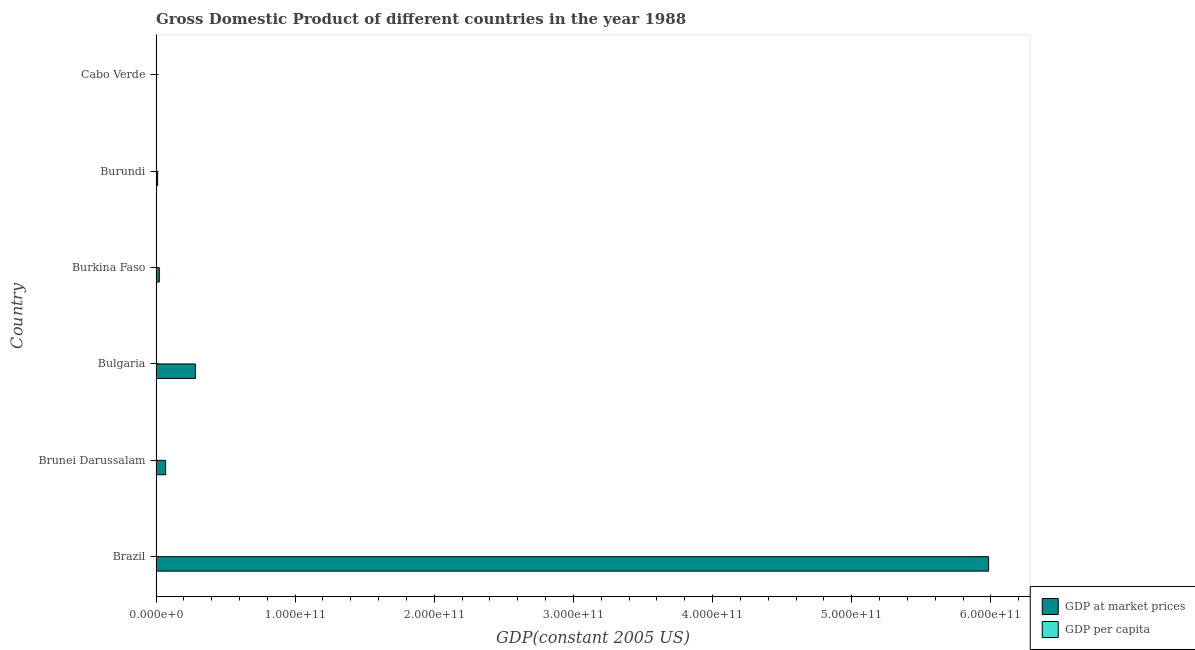How many different coloured bars are there?
Your answer should be very brief. 2. How many groups of bars are there?
Your answer should be very brief. 6. How many bars are there on the 3rd tick from the top?
Make the answer very short. 2. What is the label of the 4th group of bars from the top?
Give a very brief answer. Bulgaria. What is the gdp per capita in Burkina Faso?
Provide a short and direct response. 281.81. Across all countries, what is the maximum gdp at market prices?
Give a very brief answer. 5.98e+11. Across all countries, what is the minimum gdp at market prices?
Make the answer very short. 2.35e+08. In which country was the gdp at market prices maximum?
Keep it short and to the point. Brazil. In which country was the gdp at market prices minimum?
Provide a succinct answer. Cabo Verde. What is the total gdp per capita in the graph?
Your response must be concise. 3.69e+04. What is the difference between the gdp per capita in Burkina Faso and that in Cabo Verde?
Ensure brevity in your answer.  -432.06. What is the difference between the gdp per capita in Bulgaria and the gdp at market prices in Brazil?
Give a very brief answer. -5.98e+11. What is the average gdp per capita per country?
Give a very brief answer. 6148.14. What is the difference between the gdp per capita and gdp at market prices in Brunei Darussalam?
Your answer should be very brief. -6.89e+09. In how many countries, is the gdp per capita greater than 460000000000 US$?
Make the answer very short. 0. What is the ratio of the gdp per capita in Brazil to that in Brunei Darussalam?
Your answer should be very brief. 0.14. Is the gdp at market prices in Brunei Darussalam less than that in Bulgaria?
Make the answer very short. Yes. What is the difference between the highest and the second highest gdp at market prices?
Keep it short and to the point. 5.70e+11. What is the difference between the highest and the lowest gdp per capita?
Make the answer very short. 2.82e+04. Is the sum of the gdp per capita in Brazil and Burkina Faso greater than the maximum gdp at market prices across all countries?
Keep it short and to the point. No. What does the 1st bar from the top in Bulgaria represents?
Keep it short and to the point. GDP per capita. What does the 2nd bar from the bottom in Burundi represents?
Your answer should be compact. GDP per capita. How many bars are there?
Offer a terse response. 12. Are all the bars in the graph horizontal?
Your answer should be very brief. Yes. How many countries are there in the graph?
Your response must be concise. 6. What is the difference between two consecutive major ticks on the X-axis?
Offer a very short reply. 1.00e+11. Are the values on the major ticks of X-axis written in scientific E-notation?
Keep it short and to the point. Yes. How are the legend labels stacked?
Make the answer very short. Vertical. What is the title of the graph?
Give a very brief answer. Gross Domestic Product of different countries in the year 1988. Does "Diesel" appear as one of the legend labels in the graph?
Keep it short and to the point. No. What is the label or title of the X-axis?
Give a very brief answer. GDP(constant 2005 US). What is the label or title of the Y-axis?
Your answer should be compact. Country. What is the GDP(constant 2005 US) in GDP at market prices in Brazil?
Provide a short and direct response. 5.98e+11. What is the GDP(constant 2005 US) of GDP per capita in Brazil?
Your answer should be compact. 4122.42. What is the GDP(constant 2005 US) of GDP at market prices in Brunei Darussalam?
Keep it short and to the point. 6.89e+09. What is the GDP(constant 2005 US) in GDP per capita in Brunei Darussalam?
Give a very brief answer. 2.84e+04. What is the GDP(constant 2005 US) of GDP at market prices in Bulgaria?
Ensure brevity in your answer.  2.83e+1. What is the GDP(constant 2005 US) of GDP per capita in Bulgaria?
Your answer should be very brief. 3152.69. What is the GDP(constant 2005 US) in GDP at market prices in Burkina Faso?
Provide a short and direct response. 2.35e+09. What is the GDP(constant 2005 US) of GDP per capita in Burkina Faso?
Your answer should be very brief. 281.81. What is the GDP(constant 2005 US) in GDP at market prices in Burundi?
Offer a terse response. 1.17e+09. What is the GDP(constant 2005 US) of GDP per capita in Burundi?
Make the answer very short. 220.82. What is the GDP(constant 2005 US) of GDP at market prices in Cabo Verde?
Ensure brevity in your answer.  2.35e+08. What is the GDP(constant 2005 US) in GDP per capita in Cabo Verde?
Provide a short and direct response. 713.87. Across all countries, what is the maximum GDP(constant 2005 US) of GDP at market prices?
Your response must be concise. 5.98e+11. Across all countries, what is the maximum GDP(constant 2005 US) in GDP per capita?
Offer a very short reply. 2.84e+04. Across all countries, what is the minimum GDP(constant 2005 US) in GDP at market prices?
Make the answer very short. 2.35e+08. Across all countries, what is the minimum GDP(constant 2005 US) in GDP per capita?
Give a very brief answer. 220.82. What is the total GDP(constant 2005 US) of GDP at market prices in the graph?
Offer a terse response. 6.37e+11. What is the total GDP(constant 2005 US) of GDP per capita in the graph?
Your answer should be very brief. 3.69e+04. What is the difference between the GDP(constant 2005 US) in GDP at market prices in Brazil and that in Brunei Darussalam?
Give a very brief answer. 5.91e+11. What is the difference between the GDP(constant 2005 US) of GDP per capita in Brazil and that in Brunei Darussalam?
Give a very brief answer. -2.43e+04. What is the difference between the GDP(constant 2005 US) of GDP at market prices in Brazil and that in Bulgaria?
Make the answer very short. 5.70e+11. What is the difference between the GDP(constant 2005 US) of GDP per capita in Brazil and that in Bulgaria?
Provide a succinct answer. 969.72. What is the difference between the GDP(constant 2005 US) of GDP at market prices in Brazil and that in Burkina Faso?
Make the answer very short. 5.96e+11. What is the difference between the GDP(constant 2005 US) in GDP per capita in Brazil and that in Burkina Faso?
Your response must be concise. 3840.61. What is the difference between the GDP(constant 2005 US) of GDP at market prices in Brazil and that in Burundi?
Provide a short and direct response. 5.97e+11. What is the difference between the GDP(constant 2005 US) in GDP per capita in Brazil and that in Burundi?
Provide a succinct answer. 3901.59. What is the difference between the GDP(constant 2005 US) in GDP at market prices in Brazil and that in Cabo Verde?
Your answer should be very brief. 5.98e+11. What is the difference between the GDP(constant 2005 US) in GDP per capita in Brazil and that in Cabo Verde?
Make the answer very short. 3408.55. What is the difference between the GDP(constant 2005 US) in GDP at market prices in Brunei Darussalam and that in Bulgaria?
Provide a succinct answer. -2.14e+1. What is the difference between the GDP(constant 2005 US) of GDP per capita in Brunei Darussalam and that in Bulgaria?
Ensure brevity in your answer.  2.52e+04. What is the difference between the GDP(constant 2005 US) of GDP at market prices in Brunei Darussalam and that in Burkina Faso?
Provide a succinct answer. 4.54e+09. What is the difference between the GDP(constant 2005 US) of GDP per capita in Brunei Darussalam and that in Burkina Faso?
Offer a very short reply. 2.81e+04. What is the difference between the GDP(constant 2005 US) of GDP at market prices in Brunei Darussalam and that in Burundi?
Make the answer very short. 5.73e+09. What is the difference between the GDP(constant 2005 US) in GDP per capita in Brunei Darussalam and that in Burundi?
Your response must be concise. 2.82e+04. What is the difference between the GDP(constant 2005 US) in GDP at market prices in Brunei Darussalam and that in Cabo Verde?
Provide a succinct answer. 6.66e+09. What is the difference between the GDP(constant 2005 US) of GDP per capita in Brunei Darussalam and that in Cabo Verde?
Make the answer very short. 2.77e+04. What is the difference between the GDP(constant 2005 US) of GDP at market prices in Bulgaria and that in Burkina Faso?
Keep it short and to the point. 2.60e+1. What is the difference between the GDP(constant 2005 US) of GDP per capita in Bulgaria and that in Burkina Faso?
Offer a very short reply. 2870.89. What is the difference between the GDP(constant 2005 US) of GDP at market prices in Bulgaria and that in Burundi?
Make the answer very short. 2.71e+1. What is the difference between the GDP(constant 2005 US) of GDP per capita in Bulgaria and that in Burundi?
Keep it short and to the point. 2931.87. What is the difference between the GDP(constant 2005 US) in GDP at market prices in Bulgaria and that in Cabo Verde?
Your response must be concise. 2.81e+1. What is the difference between the GDP(constant 2005 US) of GDP per capita in Bulgaria and that in Cabo Verde?
Provide a short and direct response. 2438.82. What is the difference between the GDP(constant 2005 US) in GDP at market prices in Burkina Faso and that in Burundi?
Ensure brevity in your answer.  1.19e+09. What is the difference between the GDP(constant 2005 US) in GDP per capita in Burkina Faso and that in Burundi?
Offer a terse response. 60.99. What is the difference between the GDP(constant 2005 US) of GDP at market prices in Burkina Faso and that in Cabo Verde?
Your answer should be compact. 2.12e+09. What is the difference between the GDP(constant 2005 US) in GDP per capita in Burkina Faso and that in Cabo Verde?
Provide a short and direct response. -432.06. What is the difference between the GDP(constant 2005 US) in GDP at market prices in Burundi and that in Cabo Verde?
Your answer should be very brief. 9.32e+08. What is the difference between the GDP(constant 2005 US) in GDP per capita in Burundi and that in Cabo Verde?
Make the answer very short. -493.05. What is the difference between the GDP(constant 2005 US) of GDP at market prices in Brazil and the GDP(constant 2005 US) of GDP per capita in Brunei Darussalam?
Offer a very short reply. 5.98e+11. What is the difference between the GDP(constant 2005 US) in GDP at market prices in Brazil and the GDP(constant 2005 US) in GDP per capita in Bulgaria?
Give a very brief answer. 5.98e+11. What is the difference between the GDP(constant 2005 US) of GDP at market prices in Brazil and the GDP(constant 2005 US) of GDP per capita in Burkina Faso?
Your answer should be compact. 5.98e+11. What is the difference between the GDP(constant 2005 US) of GDP at market prices in Brazil and the GDP(constant 2005 US) of GDP per capita in Burundi?
Keep it short and to the point. 5.98e+11. What is the difference between the GDP(constant 2005 US) of GDP at market prices in Brazil and the GDP(constant 2005 US) of GDP per capita in Cabo Verde?
Provide a succinct answer. 5.98e+11. What is the difference between the GDP(constant 2005 US) in GDP at market prices in Brunei Darussalam and the GDP(constant 2005 US) in GDP per capita in Bulgaria?
Your answer should be very brief. 6.89e+09. What is the difference between the GDP(constant 2005 US) of GDP at market prices in Brunei Darussalam and the GDP(constant 2005 US) of GDP per capita in Burkina Faso?
Your answer should be compact. 6.89e+09. What is the difference between the GDP(constant 2005 US) of GDP at market prices in Brunei Darussalam and the GDP(constant 2005 US) of GDP per capita in Burundi?
Your answer should be very brief. 6.89e+09. What is the difference between the GDP(constant 2005 US) in GDP at market prices in Brunei Darussalam and the GDP(constant 2005 US) in GDP per capita in Cabo Verde?
Give a very brief answer. 6.89e+09. What is the difference between the GDP(constant 2005 US) in GDP at market prices in Bulgaria and the GDP(constant 2005 US) in GDP per capita in Burkina Faso?
Offer a very short reply. 2.83e+1. What is the difference between the GDP(constant 2005 US) in GDP at market prices in Bulgaria and the GDP(constant 2005 US) in GDP per capita in Burundi?
Your response must be concise. 2.83e+1. What is the difference between the GDP(constant 2005 US) of GDP at market prices in Bulgaria and the GDP(constant 2005 US) of GDP per capita in Cabo Verde?
Offer a very short reply. 2.83e+1. What is the difference between the GDP(constant 2005 US) in GDP at market prices in Burkina Faso and the GDP(constant 2005 US) in GDP per capita in Burundi?
Offer a very short reply. 2.35e+09. What is the difference between the GDP(constant 2005 US) of GDP at market prices in Burkina Faso and the GDP(constant 2005 US) of GDP per capita in Cabo Verde?
Your response must be concise. 2.35e+09. What is the difference between the GDP(constant 2005 US) of GDP at market prices in Burundi and the GDP(constant 2005 US) of GDP per capita in Cabo Verde?
Your answer should be compact. 1.17e+09. What is the average GDP(constant 2005 US) in GDP at market prices per country?
Make the answer very short. 1.06e+11. What is the average GDP(constant 2005 US) in GDP per capita per country?
Keep it short and to the point. 6148.14. What is the difference between the GDP(constant 2005 US) of GDP at market prices and GDP(constant 2005 US) of GDP per capita in Brazil?
Provide a short and direct response. 5.98e+11. What is the difference between the GDP(constant 2005 US) in GDP at market prices and GDP(constant 2005 US) in GDP per capita in Brunei Darussalam?
Your answer should be very brief. 6.89e+09. What is the difference between the GDP(constant 2005 US) in GDP at market prices and GDP(constant 2005 US) in GDP per capita in Bulgaria?
Your answer should be very brief. 2.83e+1. What is the difference between the GDP(constant 2005 US) of GDP at market prices and GDP(constant 2005 US) of GDP per capita in Burkina Faso?
Provide a succinct answer. 2.35e+09. What is the difference between the GDP(constant 2005 US) in GDP at market prices and GDP(constant 2005 US) in GDP per capita in Burundi?
Keep it short and to the point. 1.17e+09. What is the difference between the GDP(constant 2005 US) of GDP at market prices and GDP(constant 2005 US) of GDP per capita in Cabo Verde?
Provide a succinct answer. 2.35e+08. What is the ratio of the GDP(constant 2005 US) of GDP at market prices in Brazil to that in Brunei Darussalam?
Offer a very short reply. 86.8. What is the ratio of the GDP(constant 2005 US) in GDP per capita in Brazil to that in Brunei Darussalam?
Ensure brevity in your answer.  0.15. What is the ratio of the GDP(constant 2005 US) in GDP at market prices in Brazil to that in Bulgaria?
Your response must be concise. 21.13. What is the ratio of the GDP(constant 2005 US) in GDP per capita in Brazil to that in Bulgaria?
Your response must be concise. 1.31. What is the ratio of the GDP(constant 2005 US) in GDP at market prices in Brazil to that in Burkina Faso?
Your answer should be compact. 254.1. What is the ratio of the GDP(constant 2005 US) in GDP per capita in Brazil to that in Burkina Faso?
Ensure brevity in your answer.  14.63. What is the ratio of the GDP(constant 2005 US) in GDP at market prices in Brazil to that in Burundi?
Give a very brief answer. 512.81. What is the ratio of the GDP(constant 2005 US) in GDP per capita in Brazil to that in Burundi?
Offer a very short reply. 18.67. What is the ratio of the GDP(constant 2005 US) of GDP at market prices in Brazil to that in Cabo Verde?
Your answer should be very brief. 2548.82. What is the ratio of the GDP(constant 2005 US) of GDP per capita in Brazil to that in Cabo Verde?
Ensure brevity in your answer.  5.77. What is the ratio of the GDP(constant 2005 US) in GDP at market prices in Brunei Darussalam to that in Bulgaria?
Keep it short and to the point. 0.24. What is the ratio of the GDP(constant 2005 US) of GDP per capita in Brunei Darussalam to that in Bulgaria?
Provide a succinct answer. 9.01. What is the ratio of the GDP(constant 2005 US) in GDP at market prices in Brunei Darussalam to that in Burkina Faso?
Your answer should be very brief. 2.93. What is the ratio of the GDP(constant 2005 US) of GDP per capita in Brunei Darussalam to that in Burkina Faso?
Give a very brief answer. 100.77. What is the ratio of the GDP(constant 2005 US) in GDP at market prices in Brunei Darussalam to that in Burundi?
Your answer should be compact. 5.91. What is the ratio of the GDP(constant 2005 US) of GDP per capita in Brunei Darussalam to that in Burundi?
Offer a terse response. 128.6. What is the ratio of the GDP(constant 2005 US) of GDP at market prices in Brunei Darussalam to that in Cabo Verde?
Your answer should be very brief. 29.36. What is the ratio of the GDP(constant 2005 US) in GDP per capita in Brunei Darussalam to that in Cabo Verde?
Your answer should be very brief. 39.78. What is the ratio of the GDP(constant 2005 US) in GDP at market prices in Bulgaria to that in Burkina Faso?
Offer a terse response. 12.02. What is the ratio of the GDP(constant 2005 US) in GDP per capita in Bulgaria to that in Burkina Faso?
Give a very brief answer. 11.19. What is the ratio of the GDP(constant 2005 US) in GDP at market prices in Bulgaria to that in Burundi?
Provide a short and direct response. 24.27. What is the ratio of the GDP(constant 2005 US) of GDP per capita in Bulgaria to that in Burundi?
Your answer should be compact. 14.28. What is the ratio of the GDP(constant 2005 US) of GDP at market prices in Bulgaria to that in Cabo Verde?
Your answer should be compact. 120.61. What is the ratio of the GDP(constant 2005 US) of GDP per capita in Bulgaria to that in Cabo Verde?
Provide a succinct answer. 4.42. What is the ratio of the GDP(constant 2005 US) in GDP at market prices in Burkina Faso to that in Burundi?
Make the answer very short. 2.02. What is the ratio of the GDP(constant 2005 US) of GDP per capita in Burkina Faso to that in Burundi?
Offer a very short reply. 1.28. What is the ratio of the GDP(constant 2005 US) of GDP at market prices in Burkina Faso to that in Cabo Verde?
Give a very brief answer. 10.03. What is the ratio of the GDP(constant 2005 US) of GDP per capita in Burkina Faso to that in Cabo Verde?
Provide a succinct answer. 0.39. What is the ratio of the GDP(constant 2005 US) of GDP at market prices in Burundi to that in Cabo Verde?
Your answer should be very brief. 4.97. What is the ratio of the GDP(constant 2005 US) of GDP per capita in Burundi to that in Cabo Verde?
Give a very brief answer. 0.31. What is the difference between the highest and the second highest GDP(constant 2005 US) of GDP at market prices?
Your response must be concise. 5.70e+11. What is the difference between the highest and the second highest GDP(constant 2005 US) of GDP per capita?
Ensure brevity in your answer.  2.43e+04. What is the difference between the highest and the lowest GDP(constant 2005 US) in GDP at market prices?
Provide a short and direct response. 5.98e+11. What is the difference between the highest and the lowest GDP(constant 2005 US) of GDP per capita?
Provide a succinct answer. 2.82e+04. 